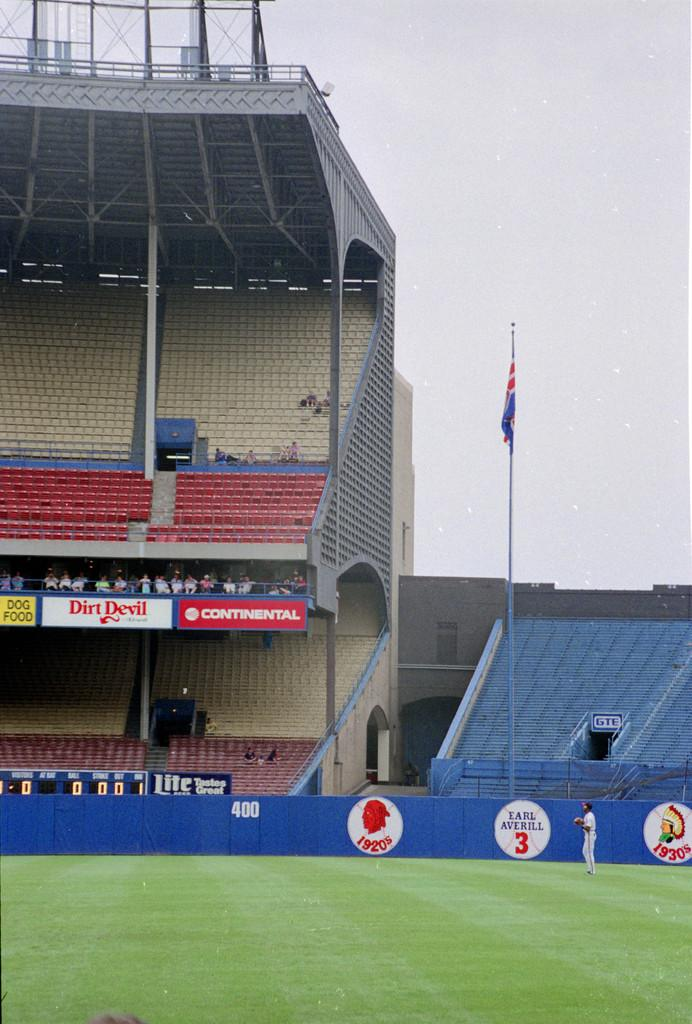<image>
Write a terse but informative summary of the picture. Stadium that shows an ad for Dirt Devil. 